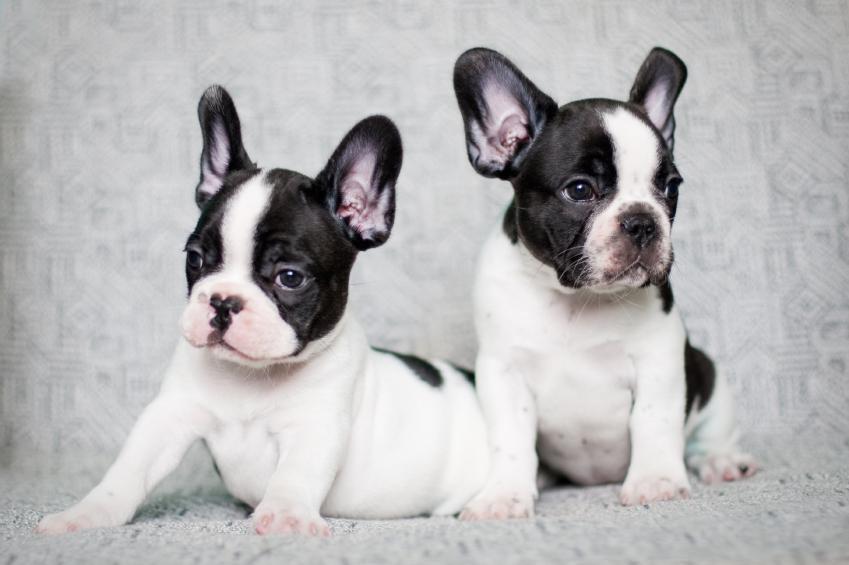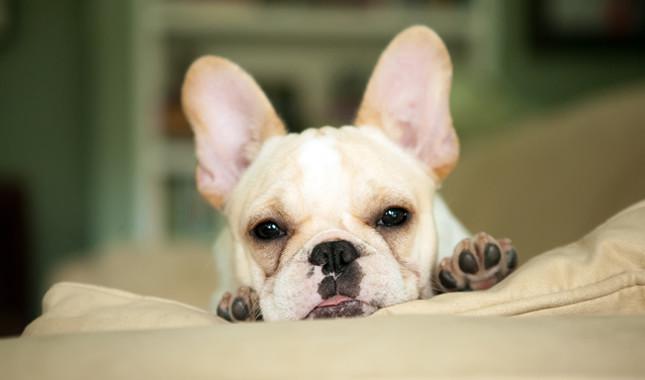The first image is the image on the left, the second image is the image on the right. For the images shown, is this caption "In one of the images there is a single puppy lying on the floor." true? Answer yes or no. No. 